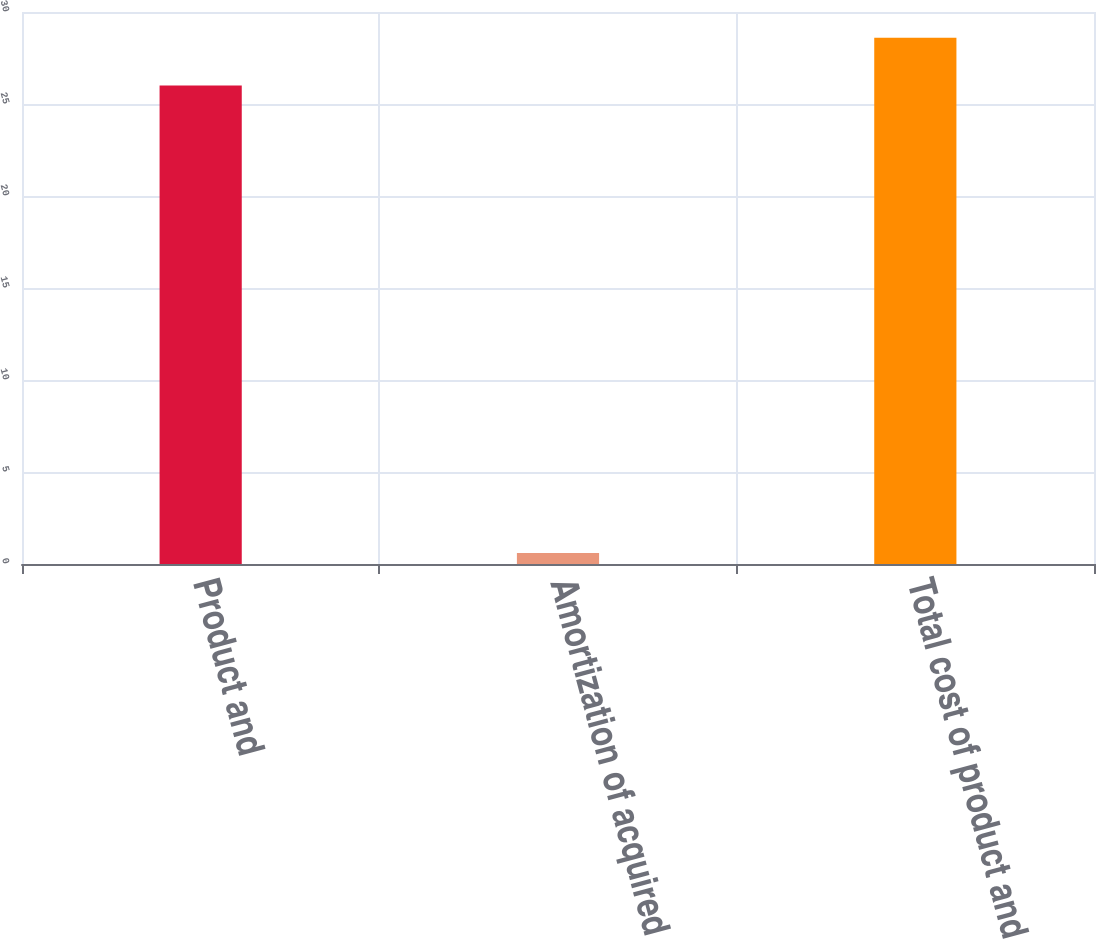Convert chart to OTSL. <chart><loc_0><loc_0><loc_500><loc_500><bar_chart><fcel>Product and<fcel>Amortization of acquired<fcel>Total cost of product and<nl><fcel>26<fcel>0.6<fcel>28.6<nl></chart> 